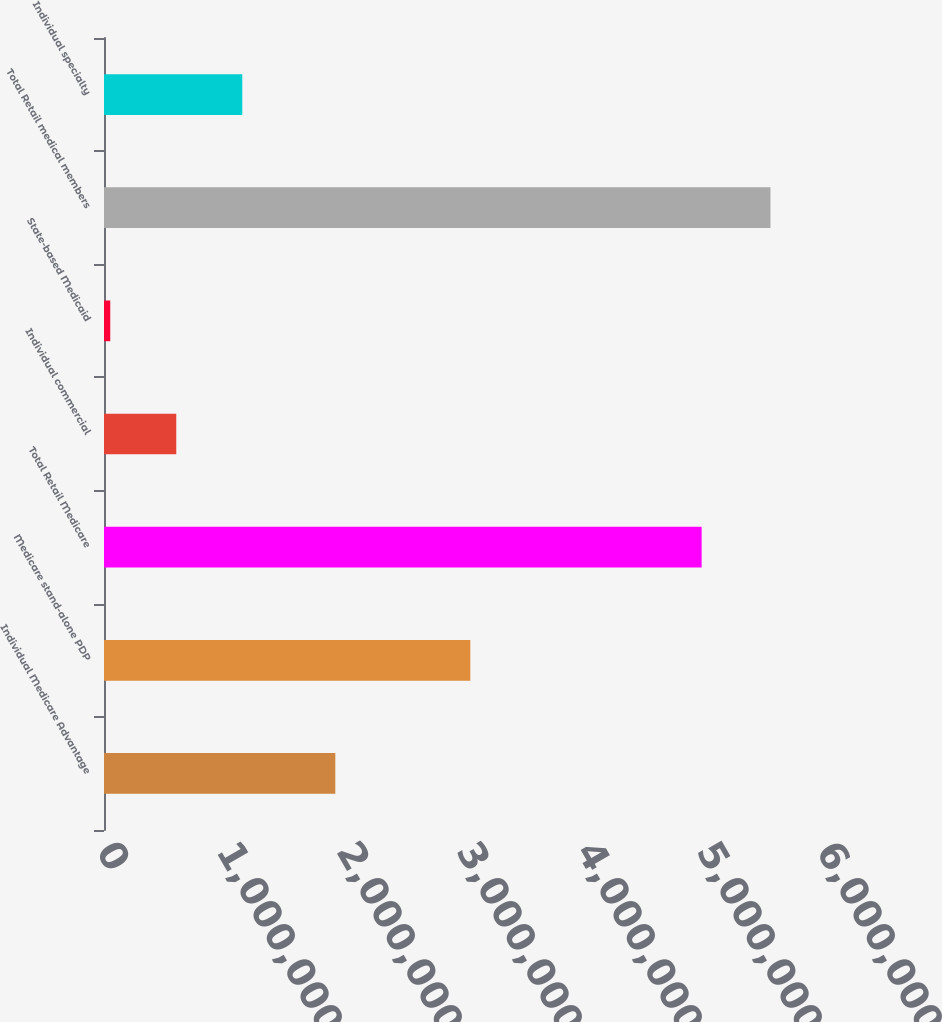<chart> <loc_0><loc_0><loc_500><loc_500><bar_chart><fcel>Individual Medicare Advantage<fcel>Medicare stand-alone PDP<fcel>Total Retail Medicare<fcel>Individual commercial<fcel>State-based Medicaid<fcel>Total Retail medical members<fcel>Individual specialty<nl><fcel>1.9276e+06<fcel>3.0527e+06<fcel>4.9803e+06<fcel>602270<fcel>52100<fcel>5.5538e+06<fcel>1.15244e+06<nl></chart> 